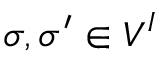Convert formula to latex. <formula><loc_0><loc_0><loc_500><loc_500>\sigma , \sigma ^ { \prime } \in V ^ { I }</formula> 